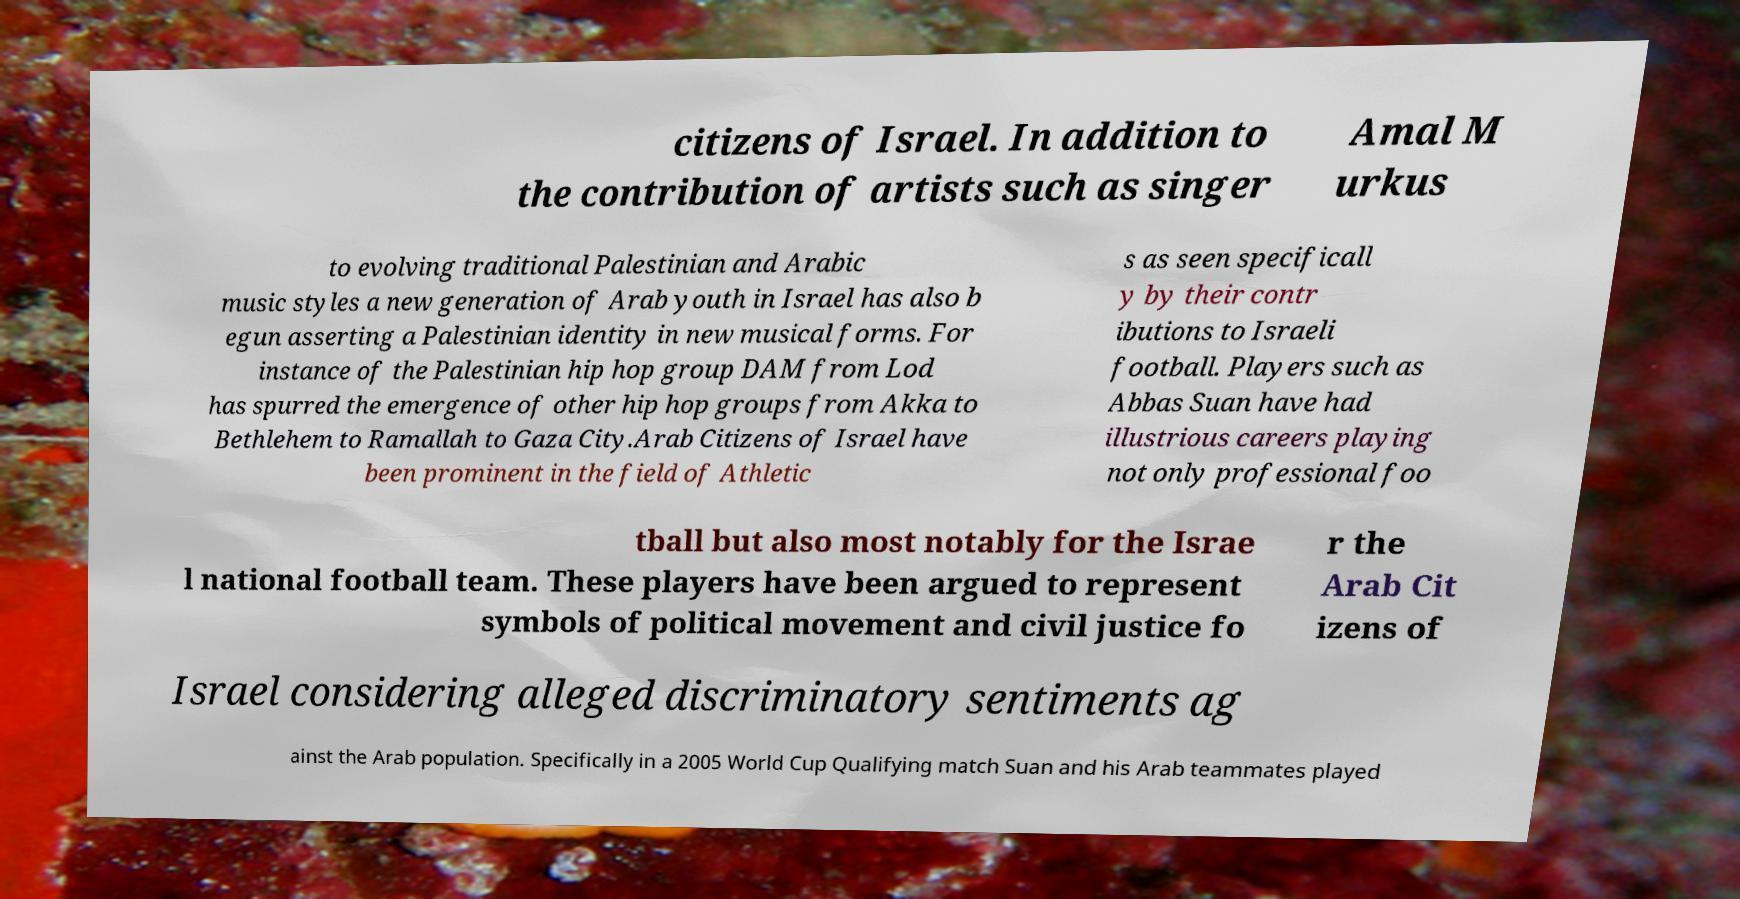There's text embedded in this image that I need extracted. Can you transcribe it verbatim? citizens of Israel. In addition to the contribution of artists such as singer Amal M urkus to evolving traditional Palestinian and Arabic music styles a new generation of Arab youth in Israel has also b egun asserting a Palestinian identity in new musical forms. For instance of the Palestinian hip hop group DAM from Lod has spurred the emergence of other hip hop groups from Akka to Bethlehem to Ramallah to Gaza City.Arab Citizens of Israel have been prominent in the field of Athletic s as seen specificall y by their contr ibutions to Israeli football. Players such as Abbas Suan have had illustrious careers playing not only professional foo tball but also most notably for the Israe l national football team. These players have been argued to represent symbols of political movement and civil justice fo r the Arab Cit izens of Israel considering alleged discriminatory sentiments ag ainst the Arab population. Specifically in a 2005 World Cup Qualifying match Suan and his Arab teammates played 